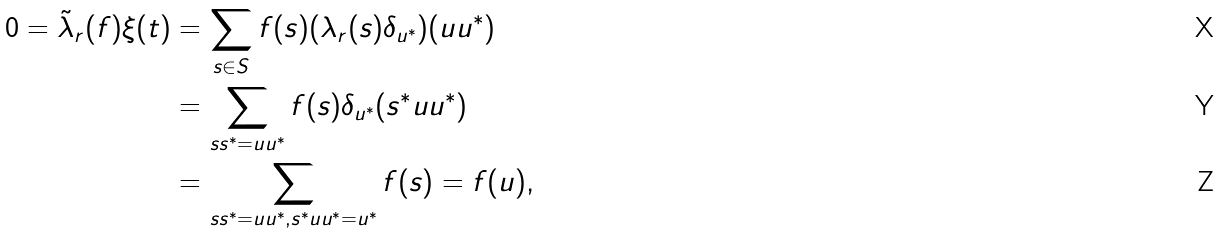<formula> <loc_0><loc_0><loc_500><loc_500>0 = \tilde { \lambda } _ { r } ( f ) \xi ( t ) & = \sum _ { s \in S } f ( s ) ( \lambda _ { r } ( s ) \delta _ { u ^ { * } } ) ( u u ^ { * } ) \\ & = \sum _ { s s ^ { * } = u u ^ { * } } f ( s ) \delta _ { u ^ { * } } ( s ^ { * } u u ^ { * } ) \\ & = \sum _ { s s ^ { * } = u u ^ { * } , s ^ { * } u u ^ { * } = u ^ { * } } f ( s ) = f ( u ) ,</formula> 